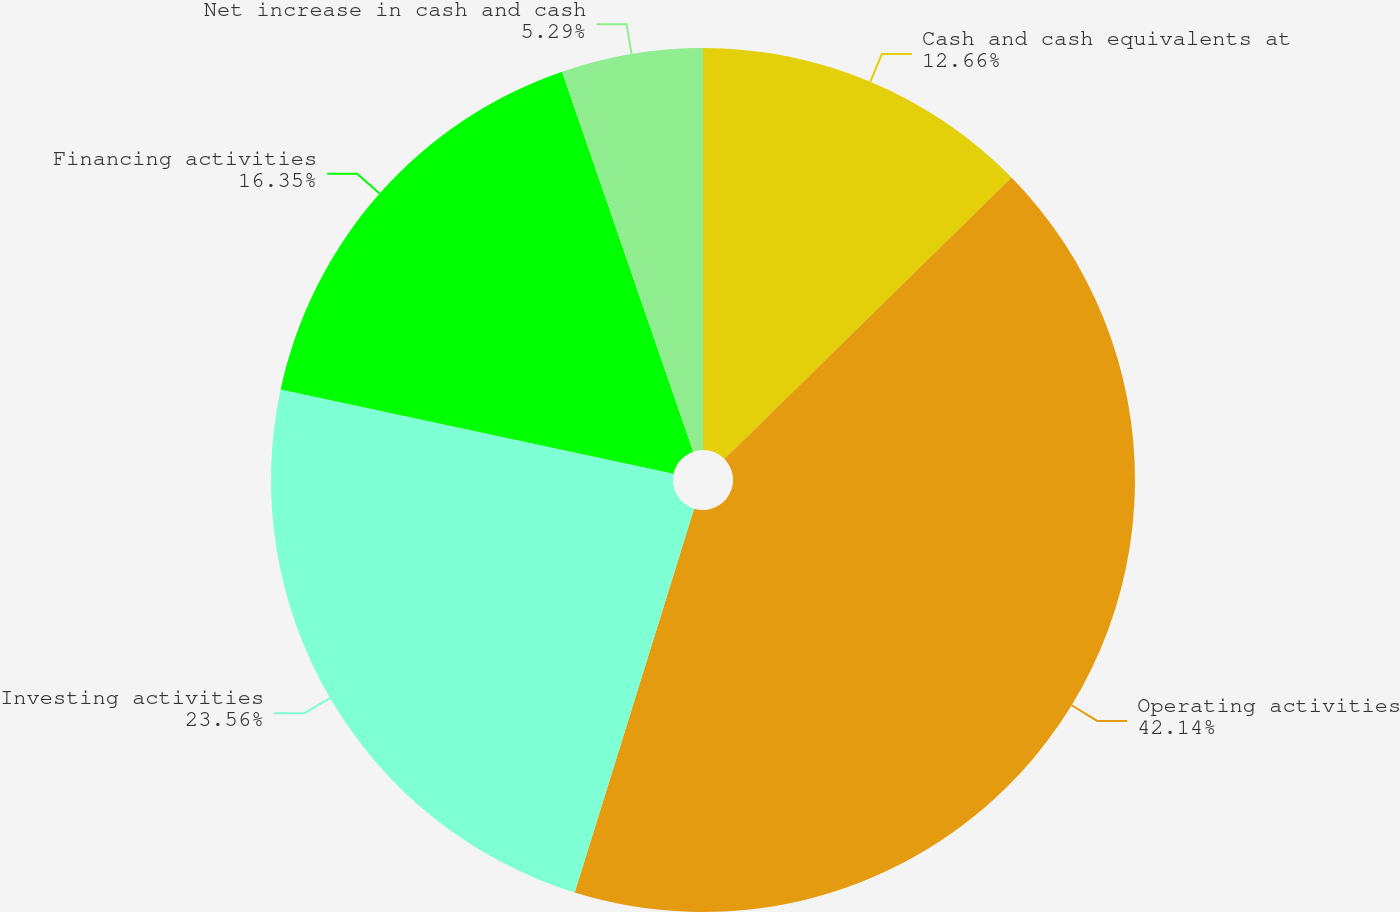Convert chart to OTSL. <chart><loc_0><loc_0><loc_500><loc_500><pie_chart><fcel>Cash and cash equivalents at<fcel>Operating activities<fcel>Investing activities<fcel>Financing activities<fcel>Net increase in cash and cash<nl><fcel>12.66%<fcel>42.14%<fcel>23.56%<fcel>16.35%<fcel>5.29%<nl></chart> 